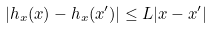Convert formula to latex. <formula><loc_0><loc_0><loc_500><loc_500>| h _ { x } ( x ) - h _ { x } ( x ^ { \prime } ) | \leq L | x - x ^ { \prime } |</formula> 